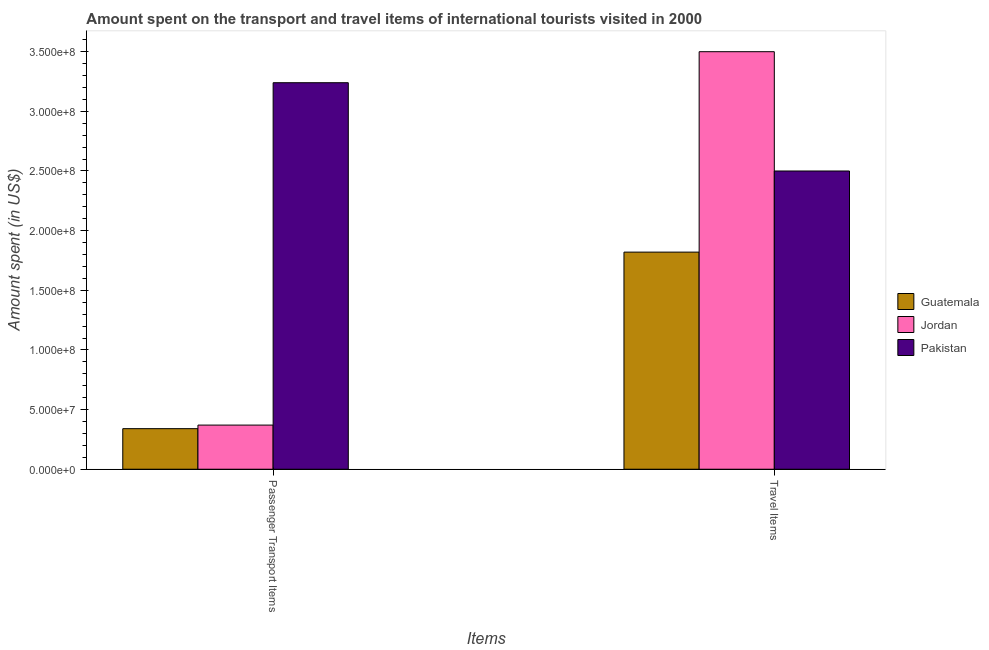How many groups of bars are there?
Give a very brief answer. 2. Are the number of bars on each tick of the X-axis equal?
Offer a terse response. Yes. What is the label of the 1st group of bars from the left?
Ensure brevity in your answer.  Passenger Transport Items. What is the amount spent in travel items in Jordan?
Your response must be concise. 3.50e+08. Across all countries, what is the maximum amount spent in travel items?
Ensure brevity in your answer.  3.50e+08. Across all countries, what is the minimum amount spent on passenger transport items?
Offer a terse response. 3.40e+07. In which country was the amount spent in travel items maximum?
Keep it short and to the point. Jordan. In which country was the amount spent in travel items minimum?
Make the answer very short. Guatemala. What is the total amount spent in travel items in the graph?
Provide a succinct answer. 7.82e+08. What is the difference between the amount spent on passenger transport items in Pakistan and that in Jordan?
Provide a succinct answer. 2.87e+08. What is the difference between the amount spent on passenger transport items in Guatemala and the amount spent in travel items in Pakistan?
Provide a succinct answer. -2.16e+08. What is the average amount spent on passenger transport items per country?
Make the answer very short. 1.32e+08. What is the difference between the amount spent in travel items and amount spent on passenger transport items in Guatemala?
Ensure brevity in your answer.  1.48e+08. What is the ratio of the amount spent in travel items in Pakistan to that in Guatemala?
Give a very brief answer. 1.37. What does the 2nd bar from the left in Travel Items represents?
Ensure brevity in your answer.  Jordan. What does the 2nd bar from the right in Travel Items represents?
Your response must be concise. Jordan. Are all the bars in the graph horizontal?
Make the answer very short. No. Are the values on the major ticks of Y-axis written in scientific E-notation?
Your response must be concise. Yes. Does the graph contain any zero values?
Make the answer very short. No. Does the graph contain grids?
Provide a short and direct response. No. Where does the legend appear in the graph?
Your response must be concise. Center right. What is the title of the graph?
Provide a succinct answer. Amount spent on the transport and travel items of international tourists visited in 2000. Does "Austria" appear as one of the legend labels in the graph?
Your answer should be compact. No. What is the label or title of the X-axis?
Offer a terse response. Items. What is the label or title of the Y-axis?
Offer a terse response. Amount spent (in US$). What is the Amount spent (in US$) in Guatemala in Passenger Transport Items?
Offer a very short reply. 3.40e+07. What is the Amount spent (in US$) in Jordan in Passenger Transport Items?
Provide a short and direct response. 3.70e+07. What is the Amount spent (in US$) of Pakistan in Passenger Transport Items?
Ensure brevity in your answer.  3.24e+08. What is the Amount spent (in US$) in Guatemala in Travel Items?
Make the answer very short. 1.82e+08. What is the Amount spent (in US$) of Jordan in Travel Items?
Offer a terse response. 3.50e+08. What is the Amount spent (in US$) of Pakistan in Travel Items?
Your answer should be very brief. 2.50e+08. Across all Items, what is the maximum Amount spent (in US$) in Guatemala?
Give a very brief answer. 1.82e+08. Across all Items, what is the maximum Amount spent (in US$) of Jordan?
Provide a succinct answer. 3.50e+08. Across all Items, what is the maximum Amount spent (in US$) in Pakistan?
Give a very brief answer. 3.24e+08. Across all Items, what is the minimum Amount spent (in US$) of Guatemala?
Your answer should be compact. 3.40e+07. Across all Items, what is the minimum Amount spent (in US$) in Jordan?
Your answer should be very brief. 3.70e+07. Across all Items, what is the minimum Amount spent (in US$) of Pakistan?
Offer a terse response. 2.50e+08. What is the total Amount spent (in US$) of Guatemala in the graph?
Your answer should be compact. 2.16e+08. What is the total Amount spent (in US$) in Jordan in the graph?
Make the answer very short. 3.87e+08. What is the total Amount spent (in US$) in Pakistan in the graph?
Keep it short and to the point. 5.74e+08. What is the difference between the Amount spent (in US$) of Guatemala in Passenger Transport Items and that in Travel Items?
Your response must be concise. -1.48e+08. What is the difference between the Amount spent (in US$) of Jordan in Passenger Transport Items and that in Travel Items?
Your answer should be very brief. -3.13e+08. What is the difference between the Amount spent (in US$) of Pakistan in Passenger Transport Items and that in Travel Items?
Provide a succinct answer. 7.40e+07. What is the difference between the Amount spent (in US$) of Guatemala in Passenger Transport Items and the Amount spent (in US$) of Jordan in Travel Items?
Your answer should be very brief. -3.16e+08. What is the difference between the Amount spent (in US$) in Guatemala in Passenger Transport Items and the Amount spent (in US$) in Pakistan in Travel Items?
Provide a short and direct response. -2.16e+08. What is the difference between the Amount spent (in US$) in Jordan in Passenger Transport Items and the Amount spent (in US$) in Pakistan in Travel Items?
Your response must be concise. -2.13e+08. What is the average Amount spent (in US$) in Guatemala per Items?
Your answer should be very brief. 1.08e+08. What is the average Amount spent (in US$) of Jordan per Items?
Give a very brief answer. 1.94e+08. What is the average Amount spent (in US$) of Pakistan per Items?
Offer a very short reply. 2.87e+08. What is the difference between the Amount spent (in US$) of Guatemala and Amount spent (in US$) of Pakistan in Passenger Transport Items?
Keep it short and to the point. -2.90e+08. What is the difference between the Amount spent (in US$) in Jordan and Amount spent (in US$) in Pakistan in Passenger Transport Items?
Your response must be concise. -2.87e+08. What is the difference between the Amount spent (in US$) of Guatemala and Amount spent (in US$) of Jordan in Travel Items?
Your response must be concise. -1.68e+08. What is the difference between the Amount spent (in US$) in Guatemala and Amount spent (in US$) in Pakistan in Travel Items?
Give a very brief answer. -6.80e+07. What is the ratio of the Amount spent (in US$) of Guatemala in Passenger Transport Items to that in Travel Items?
Your answer should be very brief. 0.19. What is the ratio of the Amount spent (in US$) of Jordan in Passenger Transport Items to that in Travel Items?
Your answer should be very brief. 0.11. What is the ratio of the Amount spent (in US$) of Pakistan in Passenger Transport Items to that in Travel Items?
Give a very brief answer. 1.3. What is the difference between the highest and the second highest Amount spent (in US$) of Guatemala?
Ensure brevity in your answer.  1.48e+08. What is the difference between the highest and the second highest Amount spent (in US$) of Jordan?
Provide a succinct answer. 3.13e+08. What is the difference between the highest and the second highest Amount spent (in US$) of Pakistan?
Your answer should be very brief. 7.40e+07. What is the difference between the highest and the lowest Amount spent (in US$) in Guatemala?
Your answer should be very brief. 1.48e+08. What is the difference between the highest and the lowest Amount spent (in US$) of Jordan?
Ensure brevity in your answer.  3.13e+08. What is the difference between the highest and the lowest Amount spent (in US$) in Pakistan?
Keep it short and to the point. 7.40e+07. 